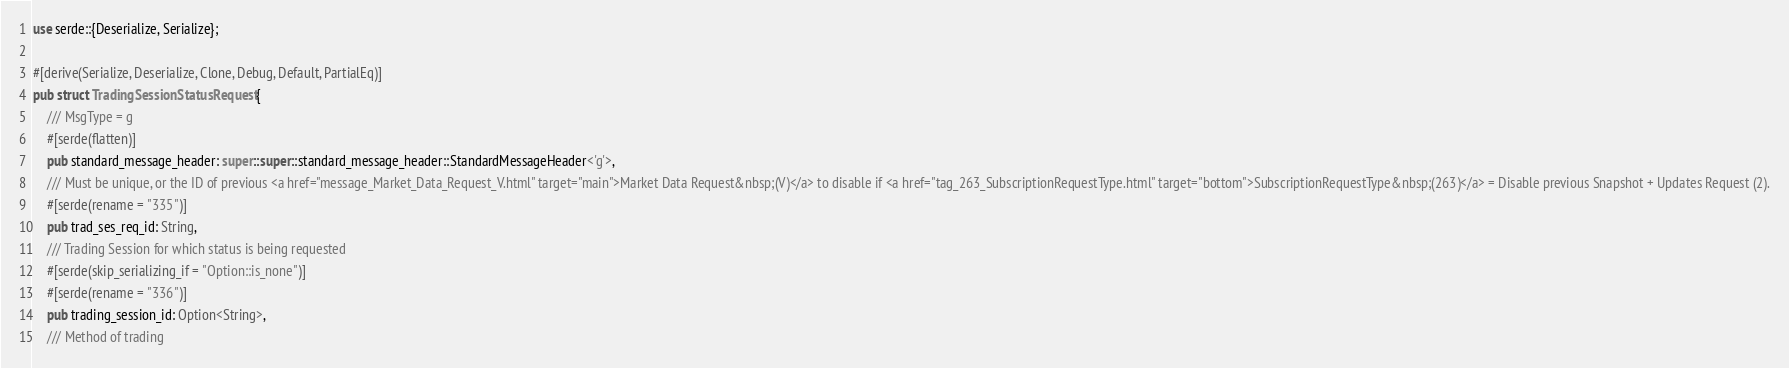Convert code to text. <code><loc_0><loc_0><loc_500><loc_500><_Rust_>
use serde::{Deserialize, Serialize};

#[derive(Serialize, Deserialize, Clone, Debug, Default, PartialEq)]
pub struct TradingSessionStatusRequest {
	/// MsgType = g
	#[serde(flatten)]
	pub standard_message_header: super::super::standard_message_header::StandardMessageHeader<'g'>,
	/// Must be unique, or the ID of previous <a href="message_Market_Data_Request_V.html" target="main">Market Data Request&nbsp;(V)</a> to disable if <a href="tag_263_SubscriptionRequestType.html" target="bottom">SubscriptionRequestType&nbsp;(263)</a> = Disable previous Snapshot + Updates Request (2).
	#[serde(rename = "335")]
	pub trad_ses_req_id: String,
	/// Trading Session for which status is being requested
	#[serde(skip_serializing_if = "Option::is_none")]
	#[serde(rename = "336")]
	pub trading_session_id: Option<String>,
	/// Method of trading</code> 